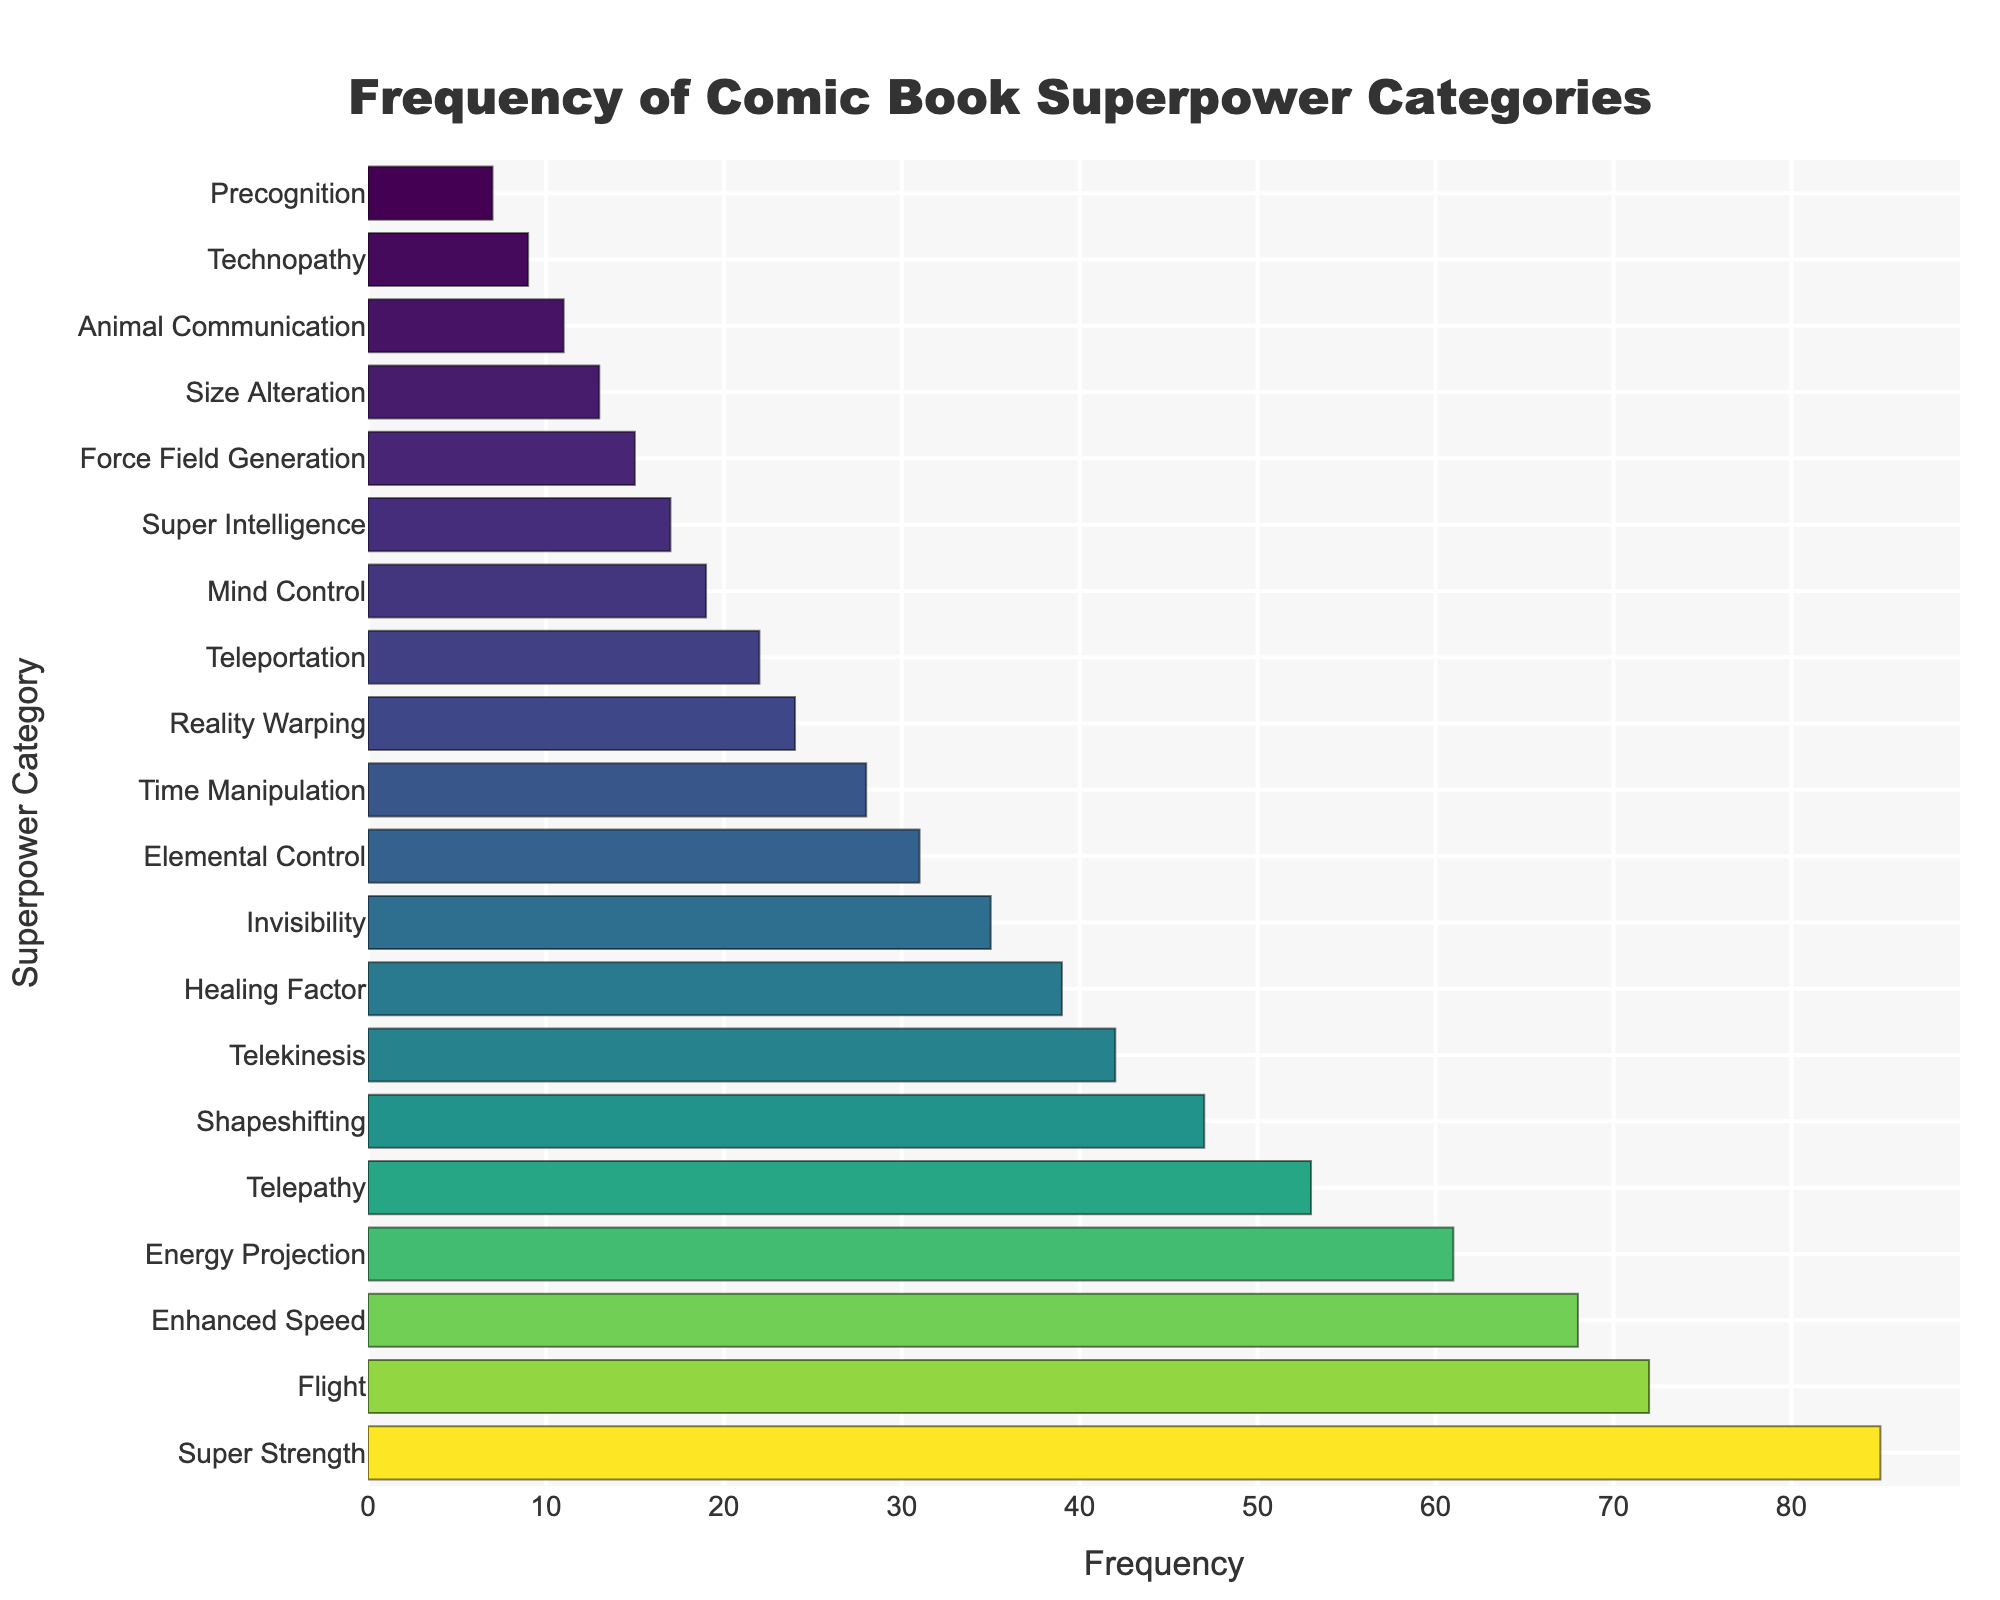Which superpower category has the highest frequency? The bar representing "Super Strength" is the longest, indicating it has the highest frequency.
Answer: Super Strength Which superpower categories have a frequency less than 10? The bars for "Technopathy" and "Precognition" are very short, indicating their frequencies are less than 10.
Answer: Technopathy, Precognition How much more frequent is "Super Strength" compared to "Healing Factor"? The frequency of "Super Strength" is 85, and the frequency of "Healing Factor" is 39. Subtracting these gives 85 - 39 = 46.
Answer: 46 What is the combined frequency of "Flight" and "Telepathy"? The frequency of "Flight" is 72, and the frequency of "Telepathy" is 53. Adding these gives 72 + 53 = 125.
Answer: 125 Which superpower category appears exactly 31 times? The bar for "Elemental Control" aligns with the value 31.
Answer: Elemental Control Compare the frequencies of "Invisibility" and "Teleportation." Which is more frequent and by how much? Invisibility has a frequency of 35, and Teleportation has a frequency of 22. Invisibility is more frequent by 35 - 22 = 13.
Answer: Invisibility by 13 What is the average frequency of the top three most frequent superpower categories? The top three categories are "Super Strength" (85), "Flight" (72), and "Enhanced Speed" (68). Their combined frequency is 85 + 72 + 68 = 225. The average is 225 / 3 = 75.
Answer: 75 Which categories have frequencies greater than 50 but less than 70? The bars for "Enhanced Speed" (68) and "Energy Projection" (61) fall within this range.
Answer: Enhanced Speed, Energy Projection Identify the least frequent superpower category and provide its frequency. The bar for "Precognition" is the shortest, indicating it has the least frequency at 7.
Answer: Precognition, 7 What is the difference in frequency between the most and least frequent categories? The most frequent category is "Super Strength" with a frequency of 85, and the least frequent is "Precognition" with a frequency of 7. The difference is 85 - 7 = 78.
Answer: 78 